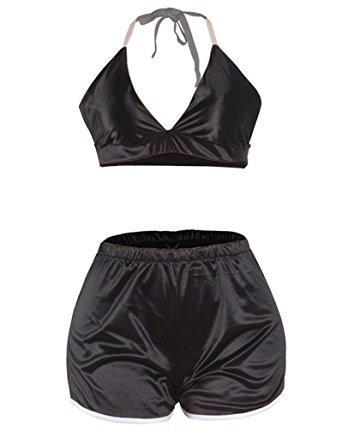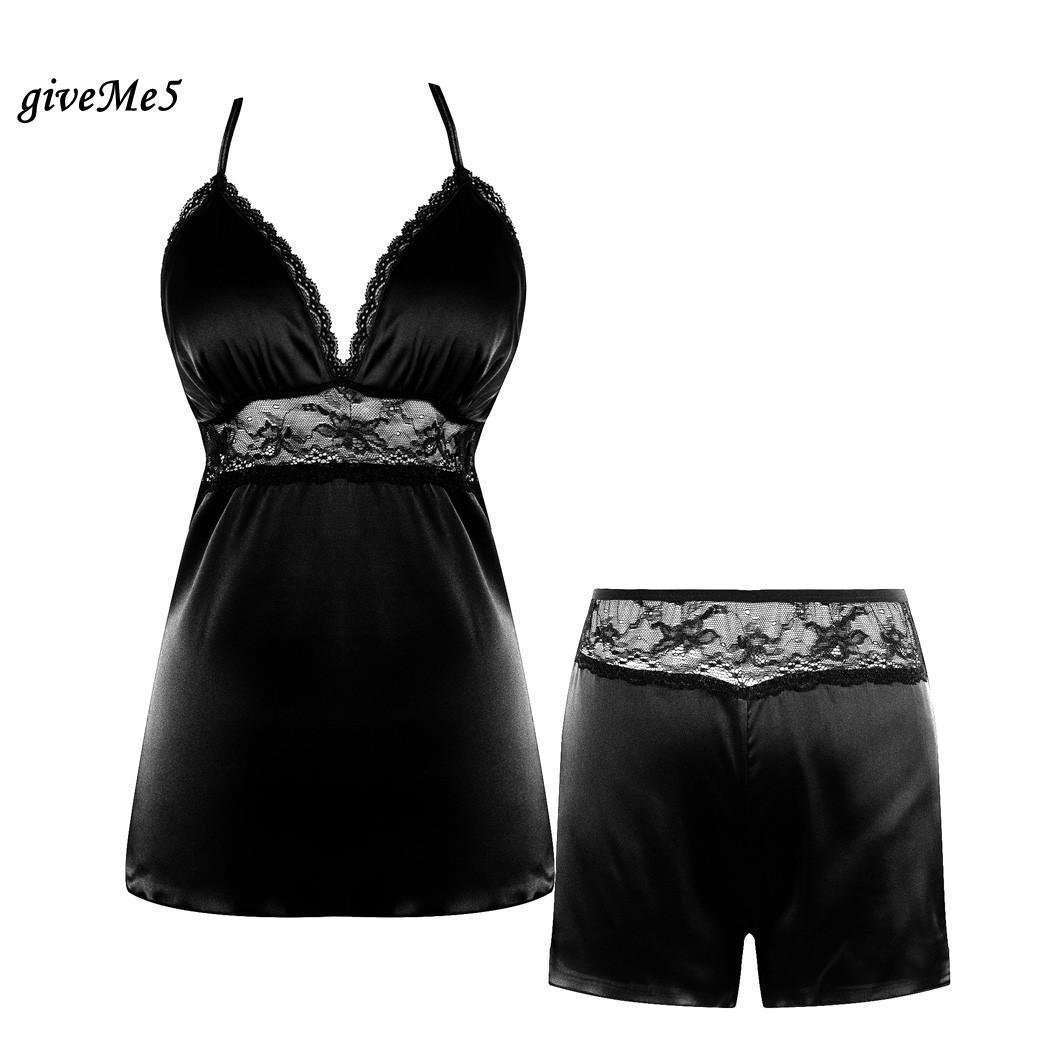The first image is the image on the left, the second image is the image on the right. Considering the images on both sides, is "One image contains a women wearing black sleep attire." valid? Answer yes or no. No. The first image is the image on the left, the second image is the image on the right. For the images displayed, is the sentence "In one image, a woman is wearing a black pajama set that is comprised of shorts and a camisole top" factually correct? Answer yes or no. No. 